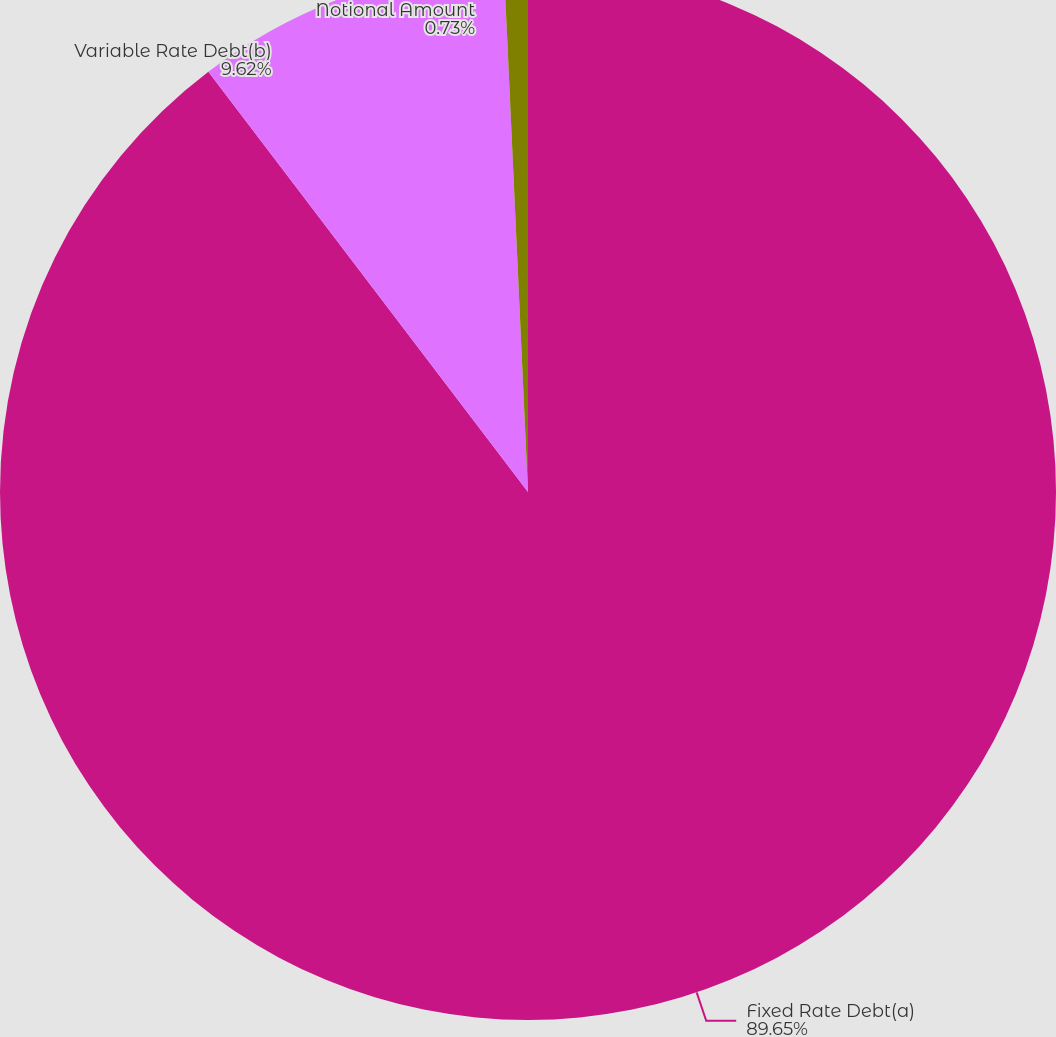<chart> <loc_0><loc_0><loc_500><loc_500><pie_chart><fcel>Fixed Rate Debt(a)<fcel>Variable Rate Debt(b)<fcel>Notional Amount<nl><fcel>89.66%<fcel>9.62%<fcel>0.73%<nl></chart> 